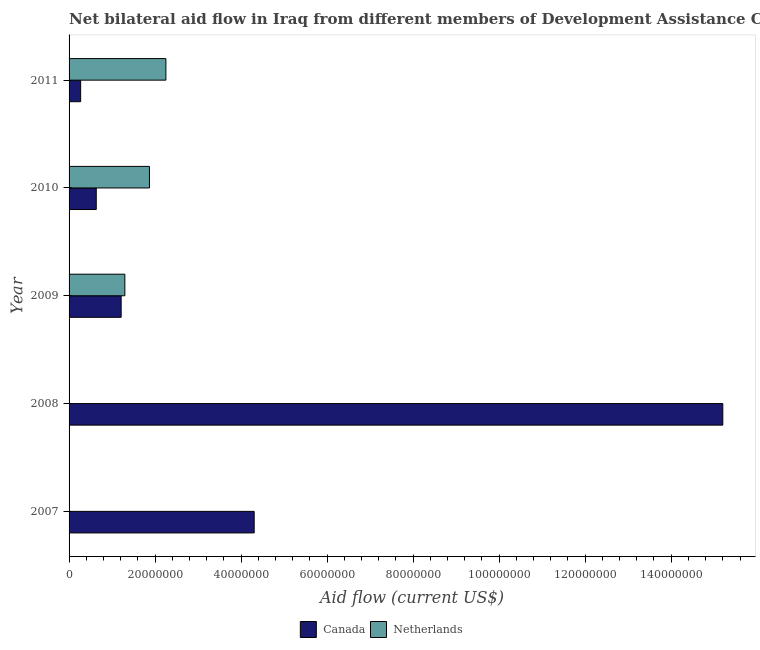How many groups of bars are there?
Provide a succinct answer. 5. In how many cases, is the number of bars for a given year not equal to the number of legend labels?
Ensure brevity in your answer.  0. What is the amount of aid given by netherlands in 2008?
Make the answer very short. 8.00e+04. Across all years, what is the maximum amount of aid given by netherlands?
Provide a short and direct response. 2.25e+07. Across all years, what is the minimum amount of aid given by canada?
Give a very brief answer. 2.69e+06. In which year was the amount of aid given by netherlands minimum?
Offer a terse response. 2007. What is the total amount of aid given by netherlands in the graph?
Your answer should be very brief. 5.43e+07. What is the difference between the amount of aid given by netherlands in 2007 and that in 2008?
Provide a succinct answer. -10000. What is the difference between the amount of aid given by netherlands in 2007 and the amount of aid given by canada in 2011?
Ensure brevity in your answer.  -2.62e+06. What is the average amount of aid given by netherlands per year?
Offer a very short reply. 1.09e+07. In the year 2011, what is the difference between the amount of aid given by netherlands and amount of aid given by canada?
Offer a very short reply. 1.98e+07. Is the amount of aid given by canada in 2007 less than that in 2011?
Give a very brief answer. No. What is the difference between the highest and the second highest amount of aid given by netherlands?
Your answer should be compact. 3.82e+06. What is the difference between the highest and the lowest amount of aid given by netherlands?
Make the answer very short. 2.24e+07. In how many years, is the amount of aid given by canada greater than the average amount of aid given by canada taken over all years?
Provide a succinct answer. 1. Is the sum of the amount of aid given by canada in 2009 and 2010 greater than the maximum amount of aid given by netherlands across all years?
Your answer should be very brief. No. What does the 1st bar from the top in 2009 represents?
Provide a short and direct response. Netherlands. What does the 2nd bar from the bottom in 2007 represents?
Ensure brevity in your answer.  Netherlands. How many bars are there?
Give a very brief answer. 10. Are all the bars in the graph horizontal?
Provide a short and direct response. Yes. How many years are there in the graph?
Offer a very short reply. 5. What is the difference between two consecutive major ticks on the X-axis?
Your answer should be compact. 2.00e+07. Does the graph contain any zero values?
Provide a short and direct response. No. Does the graph contain grids?
Ensure brevity in your answer.  No. Where does the legend appear in the graph?
Ensure brevity in your answer.  Bottom center. What is the title of the graph?
Your answer should be very brief. Net bilateral aid flow in Iraq from different members of Development Assistance Committee. What is the label or title of the X-axis?
Provide a succinct answer. Aid flow (current US$). What is the label or title of the Y-axis?
Keep it short and to the point. Year. What is the Aid flow (current US$) of Canada in 2007?
Offer a very short reply. 4.30e+07. What is the Aid flow (current US$) of Netherlands in 2007?
Your answer should be very brief. 7.00e+04. What is the Aid flow (current US$) of Canada in 2008?
Provide a succinct answer. 1.52e+08. What is the Aid flow (current US$) of Netherlands in 2008?
Your response must be concise. 8.00e+04. What is the Aid flow (current US$) of Canada in 2009?
Keep it short and to the point. 1.21e+07. What is the Aid flow (current US$) of Netherlands in 2009?
Offer a terse response. 1.30e+07. What is the Aid flow (current US$) in Canada in 2010?
Provide a succinct answer. 6.32e+06. What is the Aid flow (current US$) of Netherlands in 2010?
Provide a succinct answer. 1.87e+07. What is the Aid flow (current US$) in Canada in 2011?
Provide a short and direct response. 2.69e+06. What is the Aid flow (current US$) in Netherlands in 2011?
Provide a short and direct response. 2.25e+07. Across all years, what is the maximum Aid flow (current US$) of Canada?
Offer a terse response. 1.52e+08. Across all years, what is the maximum Aid flow (current US$) in Netherlands?
Your response must be concise. 2.25e+07. Across all years, what is the minimum Aid flow (current US$) of Canada?
Make the answer very short. 2.69e+06. What is the total Aid flow (current US$) in Canada in the graph?
Your answer should be very brief. 2.16e+08. What is the total Aid flow (current US$) of Netherlands in the graph?
Your response must be concise. 5.43e+07. What is the difference between the Aid flow (current US$) in Canada in 2007 and that in 2008?
Your answer should be compact. -1.09e+08. What is the difference between the Aid flow (current US$) of Netherlands in 2007 and that in 2008?
Ensure brevity in your answer.  -10000. What is the difference between the Aid flow (current US$) in Canada in 2007 and that in 2009?
Provide a short and direct response. 3.09e+07. What is the difference between the Aid flow (current US$) of Netherlands in 2007 and that in 2009?
Your answer should be very brief. -1.29e+07. What is the difference between the Aid flow (current US$) of Canada in 2007 and that in 2010?
Your answer should be compact. 3.67e+07. What is the difference between the Aid flow (current US$) in Netherlands in 2007 and that in 2010?
Make the answer very short. -1.86e+07. What is the difference between the Aid flow (current US$) of Canada in 2007 and that in 2011?
Your response must be concise. 4.04e+07. What is the difference between the Aid flow (current US$) in Netherlands in 2007 and that in 2011?
Offer a very short reply. -2.24e+07. What is the difference between the Aid flow (current US$) in Canada in 2008 and that in 2009?
Make the answer very short. 1.40e+08. What is the difference between the Aid flow (current US$) of Netherlands in 2008 and that in 2009?
Give a very brief answer. -1.29e+07. What is the difference between the Aid flow (current US$) of Canada in 2008 and that in 2010?
Your answer should be very brief. 1.46e+08. What is the difference between the Aid flow (current US$) of Netherlands in 2008 and that in 2010?
Offer a very short reply. -1.86e+07. What is the difference between the Aid flow (current US$) in Canada in 2008 and that in 2011?
Make the answer very short. 1.49e+08. What is the difference between the Aid flow (current US$) of Netherlands in 2008 and that in 2011?
Your answer should be very brief. -2.24e+07. What is the difference between the Aid flow (current US$) in Canada in 2009 and that in 2010?
Your response must be concise. 5.79e+06. What is the difference between the Aid flow (current US$) of Netherlands in 2009 and that in 2010?
Keep it short and to the point. -5.72e+06. What is the difference between the Aid flow (current US$) of Canada in 2009 and that in 2011?
Your response must be concise. 9.42e+06. What is the difference between the Aid flow (current US$) of Netherlands in 2009 and that in 2011?
Ensure brevity in your answer.  -9.54e+06. What is the difference between the Aid flow (current US$) in Canada in 2010 and that in 2011?
Your answer should be compact. 3.63e+06. What is the difference between the Aid flow (current US$) of Netherlands in 2010 and that in 2011?
Your answer should be very brief. -3.82e+06. What is the difference between the Aid flow (current US$) in Canada in 2007 and the Aid flow (current US$) in Netherlands in 2008?
Offer a terse response. 4.30e+07. What is the difference between the Aid flow (current US$) of Canada in 2007 and the Aid flow (current US$) of Netherlands in 2009?
Your response must be concise. 3.01e+07. What is the difference between the Aid flow (current US$) in Canada in 2007 and the Aid flow (current US$) in Netherlands in 2010?
Offer a very short reply. 2.44e+07. What is the difference between the Aid flow (current US$) in Canada in 2007 and the Aid flow (current US$) in Netherlands in 2011?
Provide a succinct answer. 2.05e+07. What is the difference between the Aid flow (current US$) of Canada in 2008 and the Aid flow (current US$) of Netherlands in 2009?
Keep it short and to the point. 1.39e+08. What is the difference between the Aid flow (current US$) in Canada in 2008 and the Aid flow (current US$) in Netherlands in 2010?
Make the answer very short. 1.33e+08. What is the difference between the Aid flow (current US$) of Canada in 2008 and the Aid flow (current US$) of Netherlands in 2011?
Keep it short and to the point. 1.29e+08. What is the difference between the Aid flow (current US$) in Canada in 2009 and the Aid flow (current US$) in Netherlands in 2010?
Your answer should be compact. -6.58e+06. What is the difference between the Aid flow (current US$) of Canada in 2009 and the Aid flow (current US$) of Netherlands in 2011?
Provide a succinct answer. -1.04e+07. What is the difference between the Aid flow (current US$) of Canada in 2010 and the Aid flow (current US$) of Netherlands in 2011?
Make the answer very short. -1.62e+07. What is the average Aid flow (current US$) of Canada per year?
Your answer should be compact. 4.32e+07. What is the average Aid flow (current US$) in Netherlands per year?
Provide a succinct answer. 1.09e+07. In the year 2007, what is the difference between the Aid flow (current US$) of Canada and Aid flow (current US$) of Netherlands?
Give a very brief answer. 4.30e+07. In the year 2008, what is the difference between the Aid flow (current US$) in Canada and Aid flow (current US$) in Netherlands?
Your answer should be compact. 1.52e+08. In the year 2009, what is the difference between the Aid flow (current US$) of Canada and Aid flow (current US$) of Netherlands?
Your response must be concise. -8.60e+05. In the year 2010, what is the difference between the Aid flow (current US$) in Canada and Aid flow (current US$) in Netherlands?
Give a very brief answer. -1.24e+07. In the year 2011, what is the difference between the Aid flow (current US$) in Canada and Aid flow (current US$) in Netherlands?
Provide a succinct answer. -1.98e+07. What is the ratio of the Aid flow (current US$) of Canada in 2007 to that in 2008?
Provide a short and direct response. 0.28. What is the ratio of the Aid flow (current US$) of Canada in 2007 to that in 2009?
Your response must be concise. 3.55. What is the ratio of the Aid flow (current US$) of Netherlands in 2007 to that in 2009?
Ensure brevity in your answer.  0.01. What is the ratio of the Aid flow (current US$) in Canada in 2007 to that in 2010?
Provide a short and direct response. 6.81. What is the ratio of the Aid flow (current US$) in Netherlands in 2007 to that in 2010?
Ensure brevity in your answer.  0. What is the ratio of the Aid flow (current US$) in Canada in 2007 to that in 2011?
Provide a succinct answer. 16. What is the ratio of the Aid flow (current US$) of Netherlands in 2007 to that in 2011?
Ensure brevity in your answer.  0. What is the ratio of the Aid flow (current US$) in Canada in 2008 to that in 2009?
Your answer should be very brief. 12.55. What is the ratio of the Aid flow (current US$) in Netherlands in 2008 to that in 2009?
Your response must be concise. 0.01. What is the ratio of the Aid flow (current US$) in Canada in 2008 to that in 2010?
Provide a short and direct response. 24.05. What is the ratio of the Aid flow (current US$) of Netherlands in 2008 to that in 2010?
Your response must be concise. 0. What is the ratio of the Aid flow (current US$) in Canada in 2008 to that in 2011?
Your response must be concise. 56.51. What is the ratio of the Aid flow (current US$) in Netherlands in 2008 to that in 2011?
Your answer should be very brief. 0. What is the ratio of the Aid flow (current US$) of Canada in 2009 to that in 2010?
Provide a short and direct response. 1.92. What is the ratio of the Aid flow (current US$) of Netherlands in 2009 to that in 2010?
Provide a succinct answer. 0.69. What is the ratio of the Aid flow (current US$) of Canada in 2009 to that in 2011?
Provide a succinct answer. 4.5. What is the ratio of the Aid flow (current US$) in Netherlands in 2009 to that in 2011?
Offer a terse response. 0.58. What is the ratio of the Aid flow (current US$) in Canada in 2010 to that in 2011?
Your answer should be compact. 2.35. What is the ratio of the Aid flow (current US$) in Netherlands in 2010 to that in 2011?
Keep it short and to the point. 0.83. What is the difference between the highest and the second highest Aid flow (current US$) of Canada?
Ensure brevity in your answer.  1.09e+08. What is the difference between the highest and the second highest Aid flow (current US$) in Netherlands?
Your answer should be very brief. 3.82e+06. What is the difference between the highest and the lowest Aid flow (current US$) in Canada?
Make the answer very short. 1.49e+08. What is the difference between the highest and the lowest Aid flow (current US$) in Netherlands?
Your answer should be very brief. 2.24e+07. 